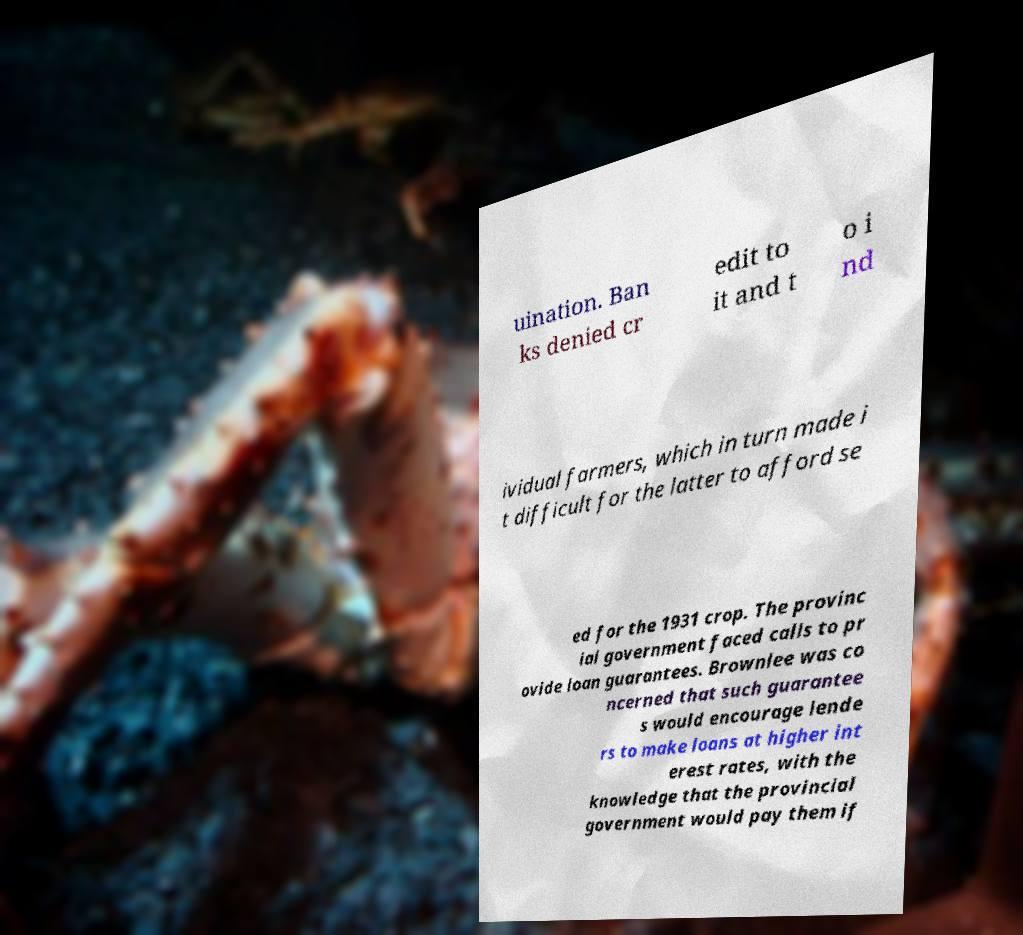There's text embedded in this image that I need extracted. Can you transcribe it verbatim? uination. Ban ks denied cr edit to it and t o i nd ividual farmers, which in turn made i t difficult for the latter to afford se ed for the 1931 crop. The provinc ial government faced calls to pr ovide loan guarantees. Brownlee was co ncerned that such guarantee s would encourage lende rs to make loans at higher int erest rates, with the knowledge that the provincial government would pay them if 